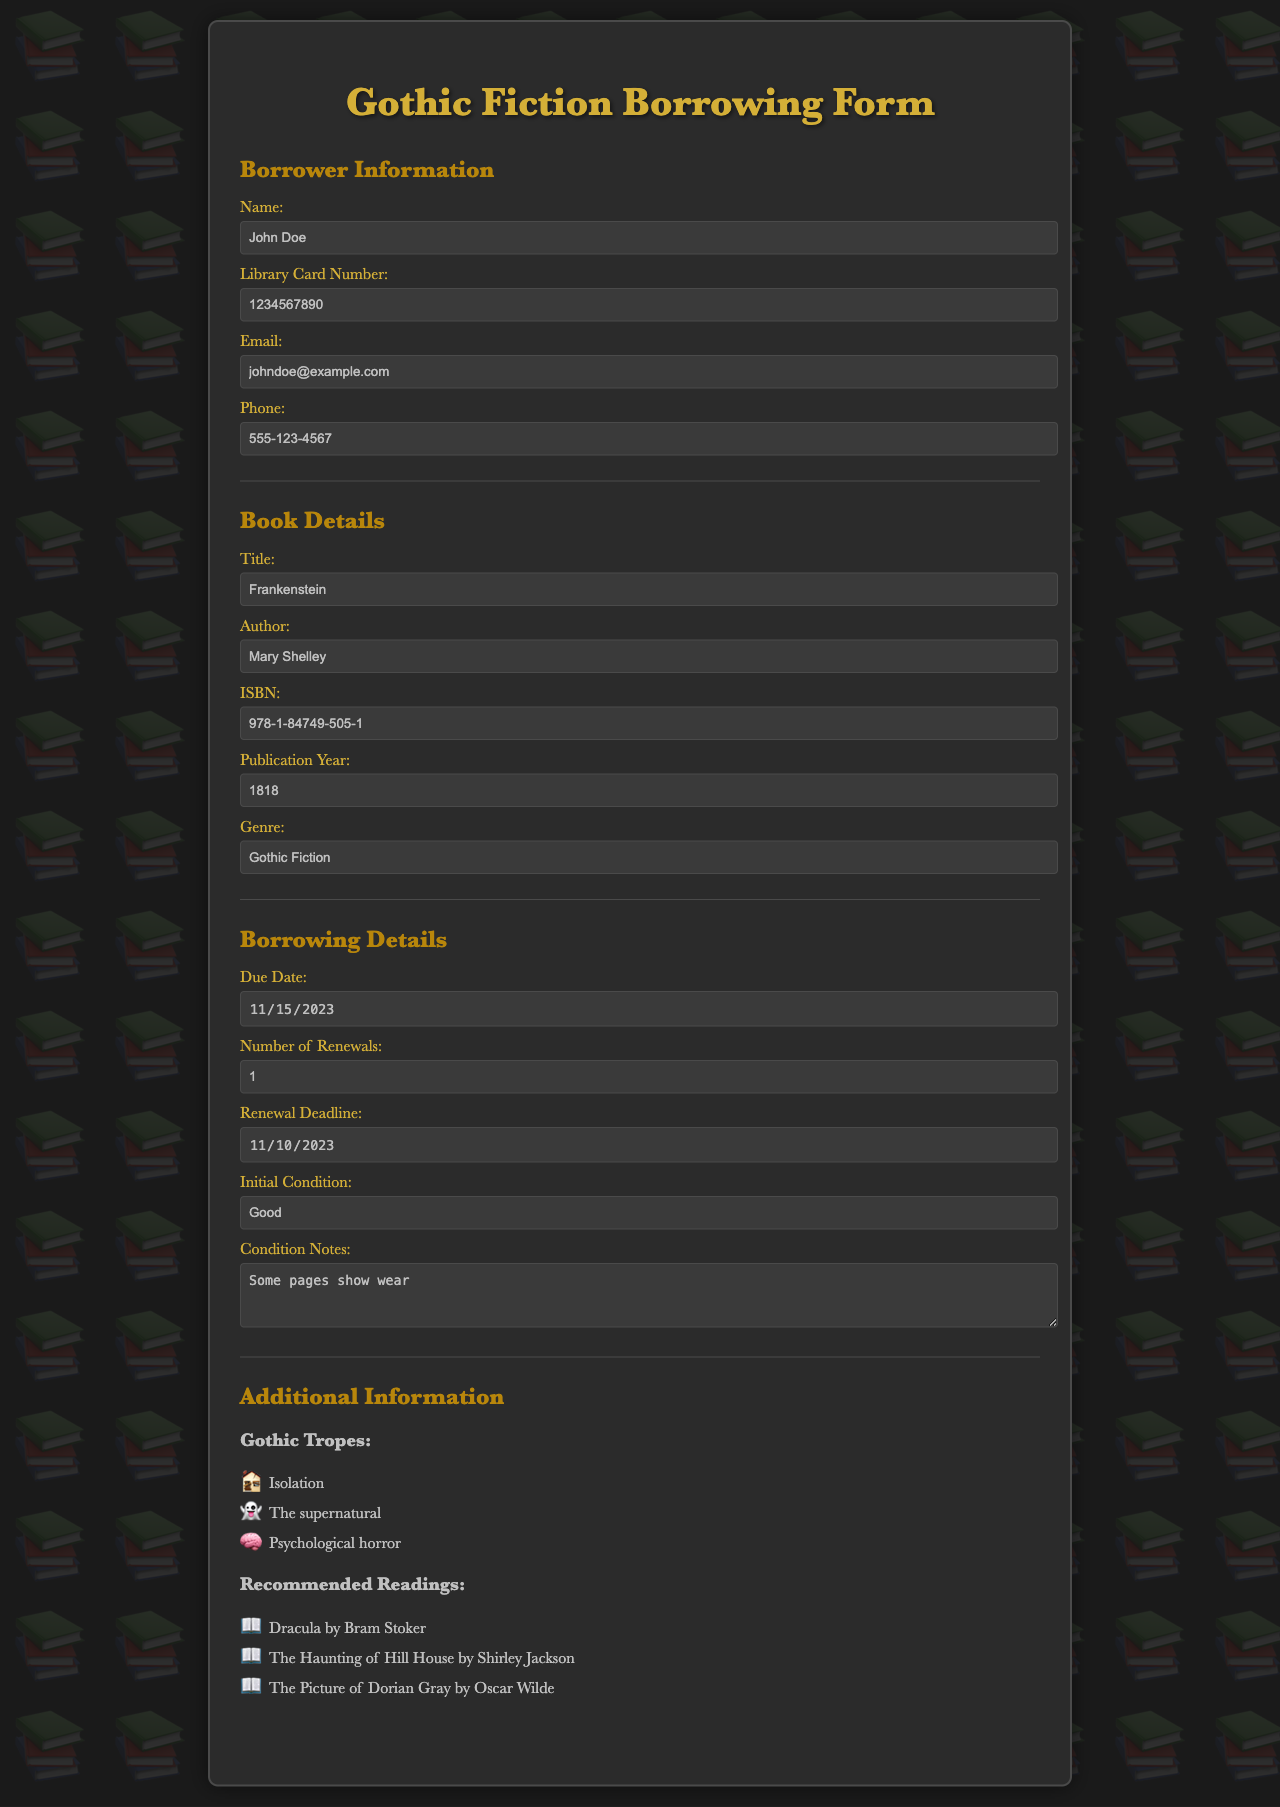What is the title of the book? The title is specified in the "Book Details" section of the document.
Answer: Frankenstein Who is the author of this gothic fiction title? The author's name is found in the same section as the title.
Answer: Mary Shelley What is the due date for the borrowed book? The due date is provided in the "Borrowing Details" section of the form.
Answer: 2023-11-15 How many renewals are allowed for this book? The number of renewals is indicated in the "Borrowing Details" section.
Answer: 1 What is the initial condition of the book? The initial condition is noted in the "Borrowing Details" section of the document.
Answer: Good What is the ISBN of the book? The ISBN is included in the "Book Details" section.
Answer: 978-1-84749-505-1 When is the renewal deadline? The renewal deadline is specified in the "Borrowing Details" section.
Answer: 2023-11-10 What genre does this book belong to? The genre is mentioned in the "Book Details" section.
Answer: Gothic Fiction What is one of the gothic tropes listed in the additional information? The gothic tropes are detailed in the "Additional Information" section.
Answer: Isolation Name one recommended reading mentioned in the document. Recommended readings are provided in the "Additional Information" section.
Answer: Dracula by Bram Stoker 